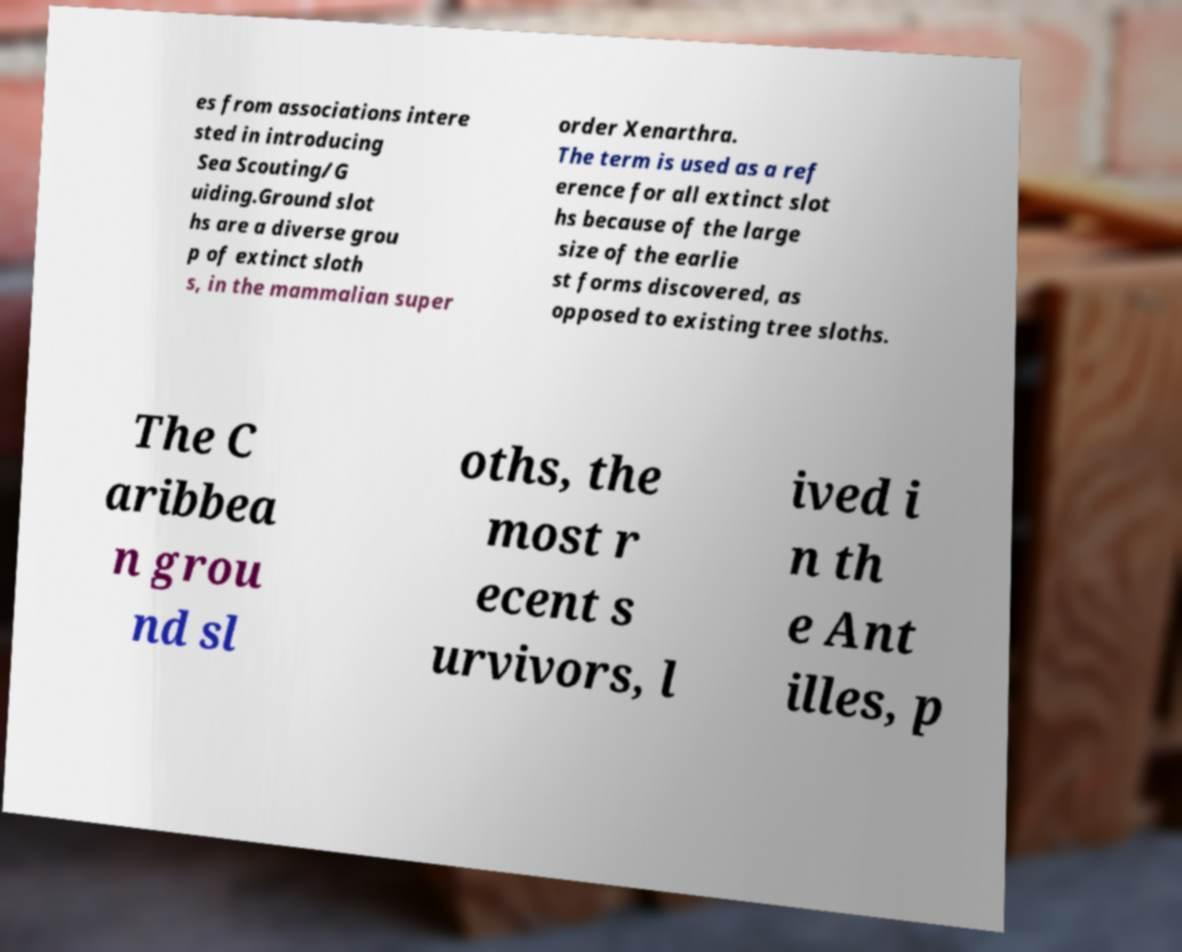There's text embedded in this image that I need extracted. Can you transcribe it verbatim? es from associations intere sted in introducing Sea Scouting/G uiding.Ground slot hs are a diverse grou p of extinct sloth s, in the mammalian super order Xenarthra. The term is used as a ref erence for all extinct slot hs because of the large size of the earlie st forms discovered, as opposed to existing tree sloths. The C aribbea n grou nd sl oths, the most r ecent s urvivors, l ived i n th e Ant illes, p 